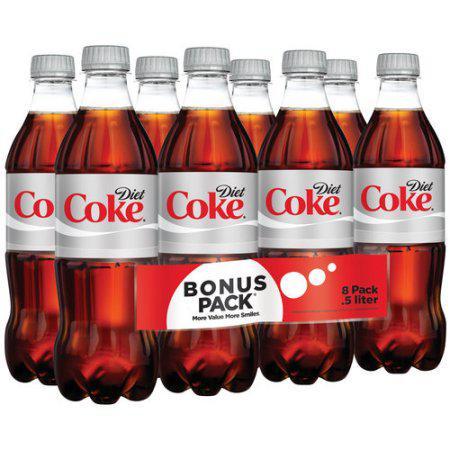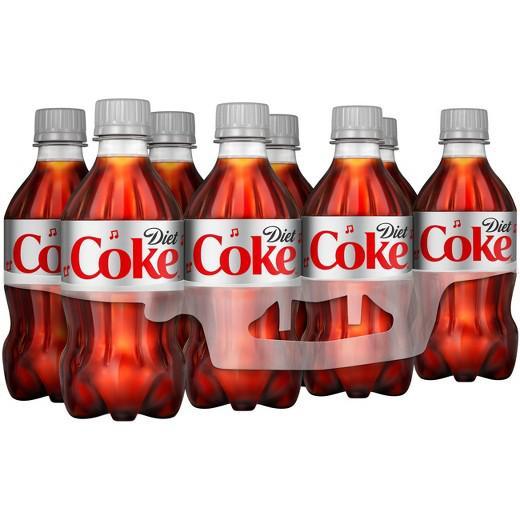The first image is the image on the left, the second image is the image on the right. For the images shown, is this caption "Each image shows a multipack of eight soda bottles with non-black caps and no box packaging, and the labels of the bottles in the right and left images are nearly identical." true? Answer yes or no. Yes. The first image is the image on the left, the second image is the image on the right. Assess this claim about the two images: "There are only eight bottles of diet coke in the image to the right; there are no extra, loose bottles.". Correct or not? Answer yes or no. Yes. 